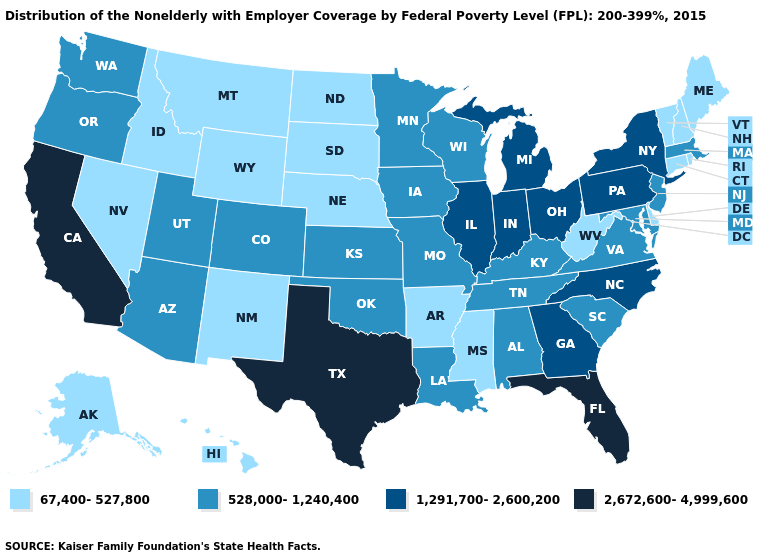Does Wyoming have a lower value than Vermont?
Concise answer only. No. Among the states that border Kentucky , does Illinois have the highest value?
Answer briefly. Yes. What is the value of Kansas?
Keep it brief. 528,000-1,240,400. Does New Mexico have a lower value than Maryland?
Quick response, please. Yes. What is the value of Alabama?
Concise answer only. 528,000-1,240,400. What is the value of North Dakota?
Keep it brief. 67,400-527,800. Is the legend a continuous bar?
Give a very brief answer. No. Name the states that have a value in the range 528,000-1,240,400?
Write a very short answer. Alabama, Arizona, Colorado, Iowa, Kansas, Kentucky, Louisiana, Maryland, Massachusetts, Minnesota, Missouri, New Jersey, Oklahoma, Oregon, South Carolina, Tennessee, Utah, Virginia, Washington, Wisconsin. Name the states that have a value in the range 1,291,700-2,600,200?
Quick response, please. Georgia, Illinois, Indiana, Michigan, New York, North Carolina, Ohio, Pennsylvania. What is the value of Wyoming?
Write a very short answer. 67,400-527,800. What is the value of Wyoming?
Give a very brief answer. 67,400-527,800. Among the states that border Michigan , does Ohio have the lowest value?
Quick response, please. No. Does the map have missing data?
Give a very brief answer. No. What is the value of Hawaii?
Keep it brief. 67,400-527,800. Among the states that border Rhode Island , does Massachusetts have the lowest value?
Short answer required. No. 